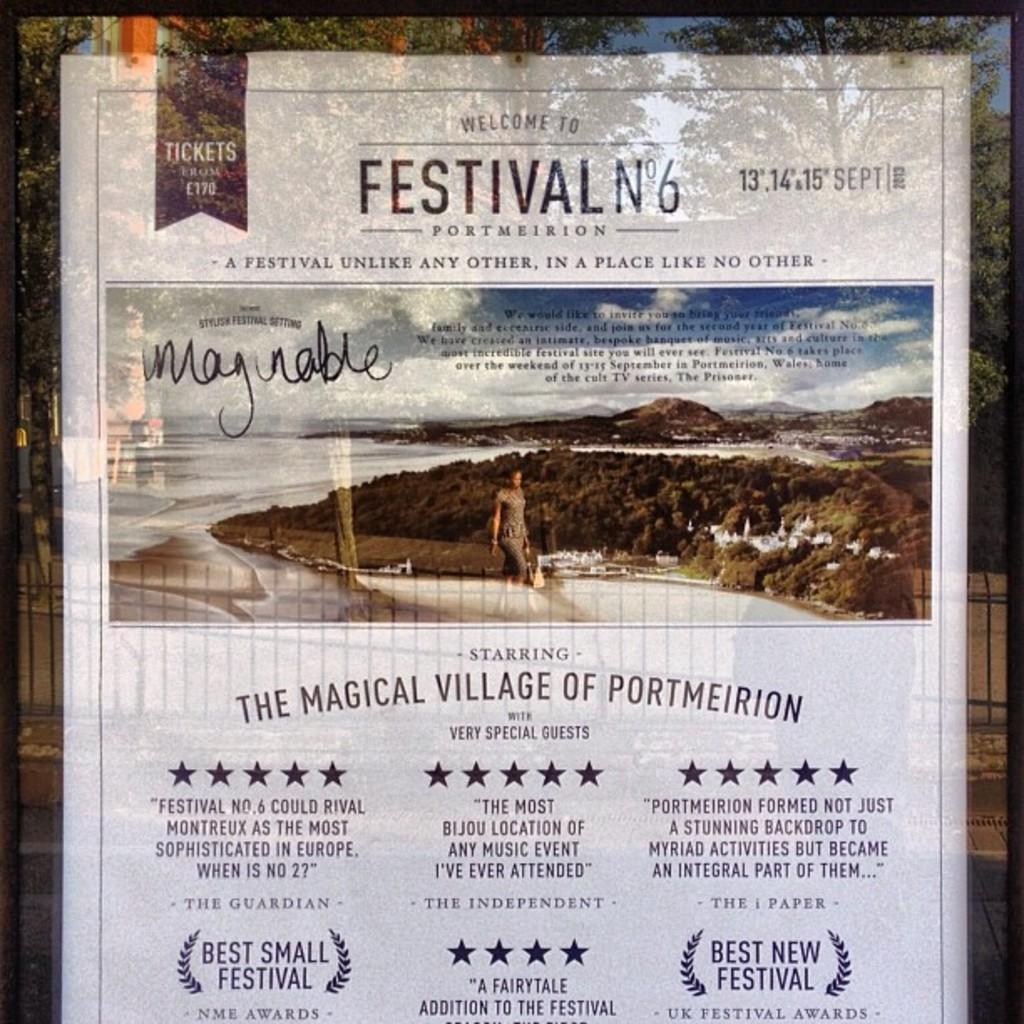<image>
Render a clear and concise summary of the photo. a festival poster for the magical village of portmeirion 